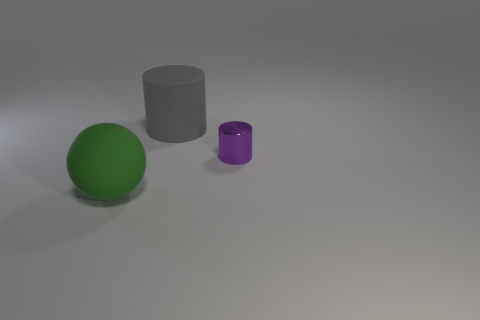Is the number of small cylinders in front of the sphere less than the number of big gray matte objects in front of the rubber cylinder? no 